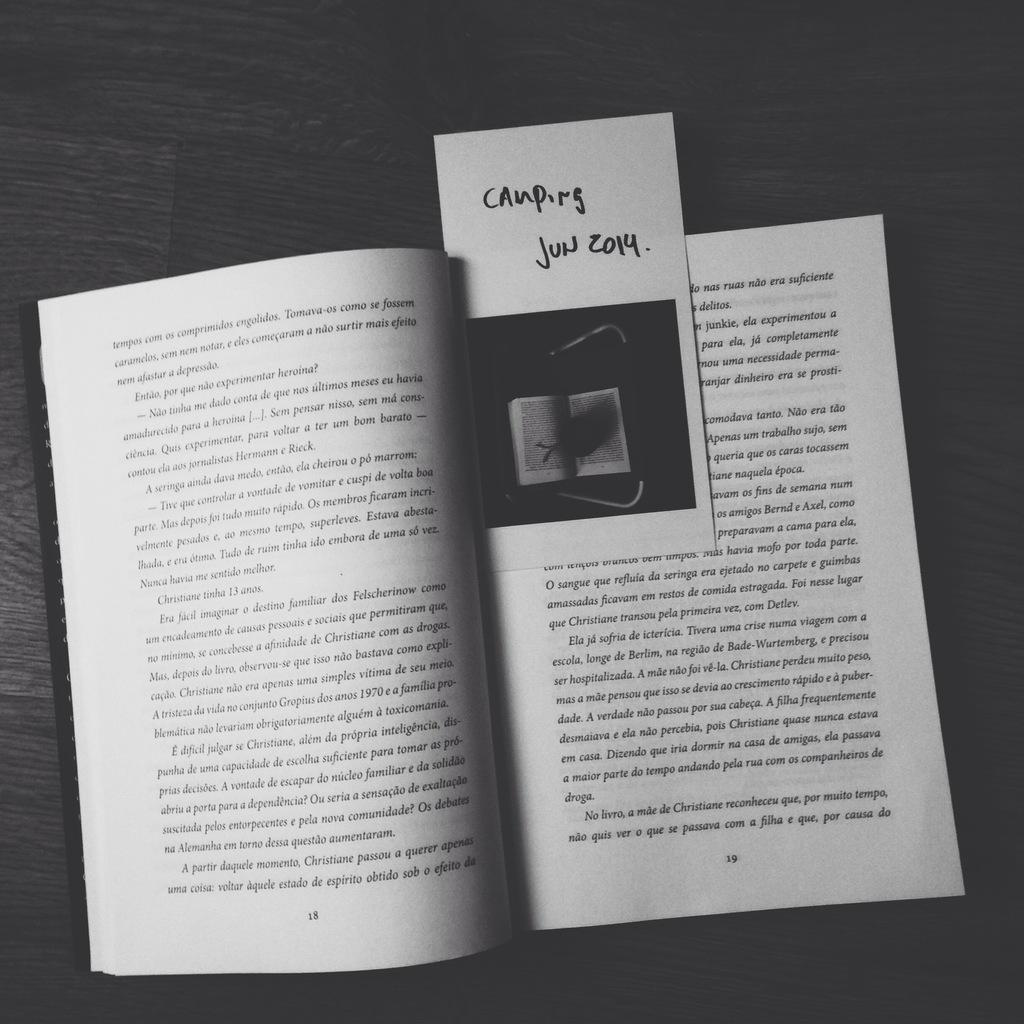Provide a one-sentence caption for the provided image. the book has a book mark showing 'Camping Jun 2014'. 